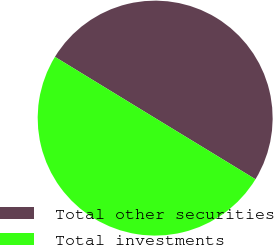<chart> <loc_0><loc_0><loc_500><loc_500><pie_chart><fcel>Total other securities<fcel>Total investments<nl><fcel>49.98%<fcel>50.02%<nl></chart> 